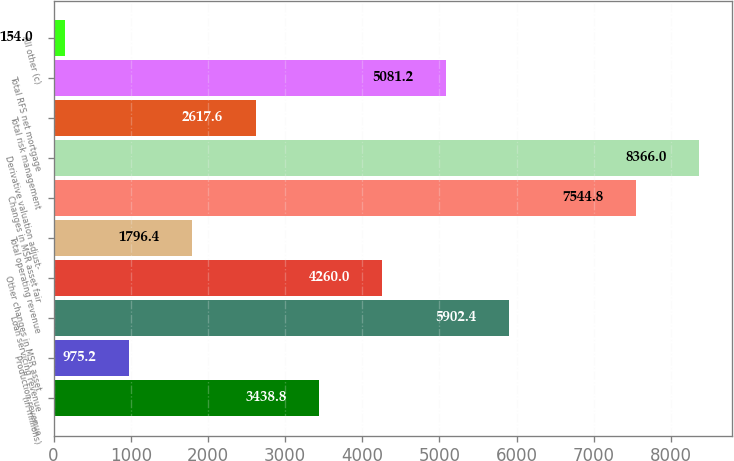<chart> <loc_0><loc_0><loc_500><loc_500><bar_chart><fcel>(in millions)<fcel>Production revenue<fcel>Loan servicing revenue<fcel>Other changes in MSR asset<fcel>Total operating revenue<fcel>Changes in MSR asset fair<fcel>Derivative valuation adjust-<fcel>Total risk management<fcel>Total RFS net mortgage<fcel>All other (c)<nl><fcel>3438.8<fcel>975.2<fcel>5902.4<fcel>4260<fcel>1796.4<fcel>7544.8<fcel>8366<fcel>2617.6<fcel>5081.2<fcel>154<nl></chart> 